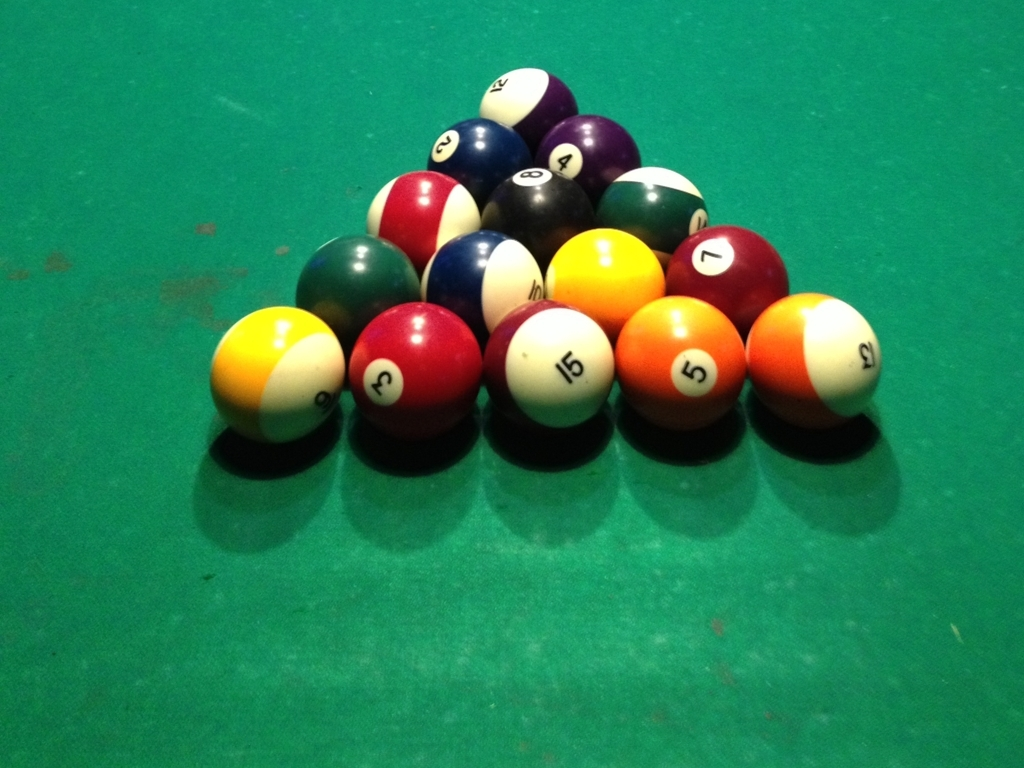The table surface looks worn. What does this indicate about the table's usage? The worn surface of the pool table suggests it has been well-used over time. Frequent play can lead to wear and tear, including fraying, fading, and the accumulation of small marks or indentations. This level of wear typically shows that the table has been a staple for regular games, often indicating a popular or communal space for pool players. How could this wear affect gameplay? The wear on a pool table can affect gameplay in several ways. A worn surface may alter the ball's trajectory, slow down its speed, or cause irregular rolls. It also might challenge players to adapt their shots, providing a unique experience compared to playing on a pristine table. 